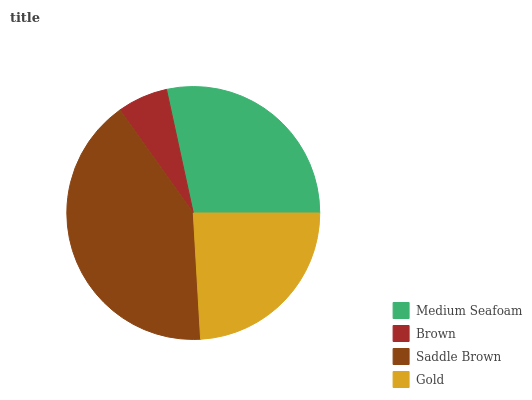Is Brown the minimum?
Answer yes or no. Yes. Is Saddle Brown the maximum?
Answer yes or no. Yes. Is Saddle Brown the minimum?
Answer yes or no. No. Is Brown the maximum?
Answer yes or no. No. Is Saddle Brown greater than Brown?
Answer yes or no. Yes. Is Brown less than Saddle Brown?
Answer yes or no. Yes. Is Brown greater than Saddle Brown?
Answer yes or no. No. Is Saddle Brown less than Brown?
Answer yes or no. No. Is Medium Seafoam the high median?
Answer yes or no. Yes. Is Gold the low median?
Answer yes or no. Yes. Is Brown the high median?
Answer yes or no. No. Is Saddle Brown the low median?
Answer yes or no. No. 